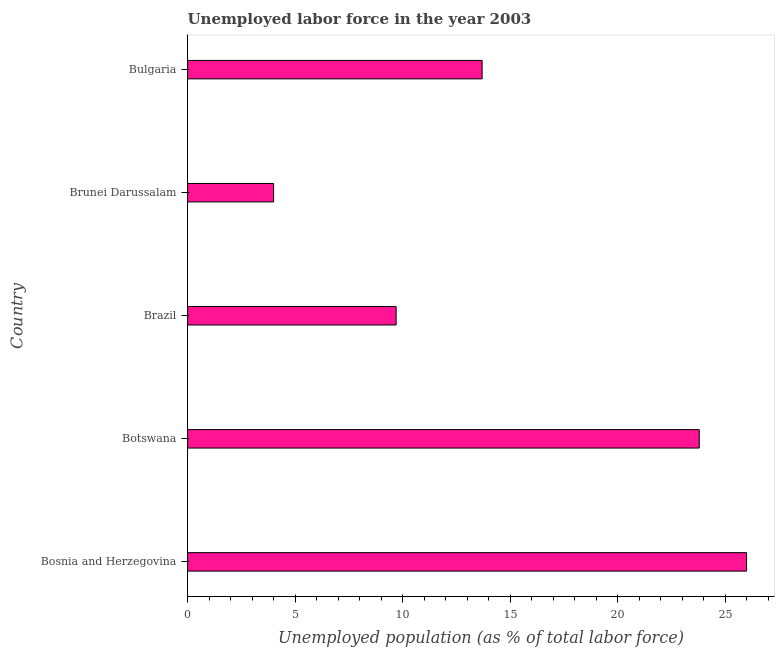Does the graph contain any zero values?
Provide a short and direct response. No. What is the title of the graph?
Keep it short and to the point. Unemployed labor force in the year 2003. What is the label or title of the X-axis?
Make the answer very short. Unemployed population (as % of total labor force). What is the total unemployed population in Brazil?
Your answer should be compact. 9.7. Across all countries, what is the maximum total unemployed population?
Provide a succinct answer. 26. Across all countries, what is the minimum total unemployed population?
Keep it short and to the point. 4. In which country was the total unemployed population maximum?
Offer a terse response. Bosnia and Herzegovina. In which country was the total unemployed population minimum?
Make the answer very short. Brunei Darussalam. What is the sum of the total unemployed population?
Your answer should be very brief. 77.2. What is the difference between the total unemployed population in Botswana and Brazil?
Give a very brief answer. 14.1. What is the average total unemployed population per country?
Provide a short and direct response. 15.44. What is the median total unemployed population?
Give a very brief answer. 13.7. What is the difference between the highest and the second highest total unemployed population?
Ensure brevity in your answer.  2.2. Is the sum of the total unemployed population in Bosnia and Herzegovina and Botswana greater than the maximum total unemployed population across all countries?
Provide a short and direct response. Yes. What is the difference between the highest and the lowest total unemployed population?
Provide a succinct answer. 22. In how many countries, is the total unemployed population greater than the average total unemployed population taken over all countries?
Offer a very short reply. 2. How many countries are there in the graph?
Ensure brevity in your answer.  5. What is the difference between two consecutive major ticks on the X-axis?
Ensure brevity in your answer.  5. What is the Unemployed population (as % of total labor force) of Botswana?
Your answer should be compact. 23.8. What is the Unemployed population (as % of total labor force) in Brazil?
Give a very brief answer. 9.7. What is the Unemployed population (as % of total labor force) in Brunei Darussalam?
Your response must be concise. 4. What is the Unemployed population (as % of total labor force) in Bulgaria?
Your answer should be compact. 13.7. What is the difference between the Unemployed population (as % of total labor force) in Bosnia and Herzegovina and Brunei Darussalam?
Keep it short and to the point. 22. What is the difference between the Unemployed population (as % of total labor force) in Bosnia and Herzegovina and Bulgaria?
Make the answer very short. 12.3. What is the difference between the Unemployed population (as % of total labor force) in Botswana and Brazil?
Offer a very short reply. 14.1. What is the difference between the Unemployed population (as % of total labor force) in Botswana and Brunei Darussalam?
Your answer should be compact. 19.8. What is the difference between the Unemployed population (as % of total labor force) in Brazil and Bulgaria?
Offer a very short reply. -4. What is the difference between the Unemployed population (as % of total labor force) in Brunei Darussalam and Bulgaria?
Offer a very short reply. -9.7. What is the ratio of the Unemployed population (as % of total labor force) in Bosnia and Herzegovina to that in Botswana?
Keep it short and to the point. 1.09. What is the ratio of the Unemployed population (as % of total labor force) in Bosnia and Herzegovina to that in Brazil?
Your response must be concise. 2.68. What is the ratio of the Unemployed population (as % of total labor force) in Bosnia and Herzegovina to that in Bulgaria?
Your response must be concise. 1.9. What is the ratio of the Unemployed population (as % of total labor force) in Botswana to that in Brazil?
Ensure brevity in your answer.  2.45. What is the ratio of the Unemployed population (as % of total labor force) in Botswana to that in Brunei Darussalam?
Your response must be concise. 5.95. What is the ratio of the Unemployed population (as % of total labor force) in Botswana to that in Bulgaria?
Keep it short and to the point. 1.74. What is the ratio of the Unemployed population (as % of total labor force) in Brazil to that in Brunei Darussalam?
Make the answer very short. 2.42. What is the ratio of the Unemployed population (as % of total labor force) in Brazil to that in Bulgaria?
Offer a terse response. 0.71. What is the ratio of the Unemployed population (as % of total labor force) in Brunei Darussalam to that in Bulgaria?
Your answer should be compact. 0.29. 